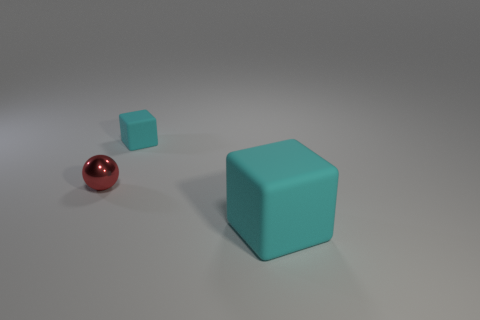What is the shape of the rubber thing that is to the right of the cyan matte object behind the ball?
Your response must be concise. Cube. Do the small cyan object behind the big cyan rubber block and the red object have the same material?
Your answer should be compact. No. How many cyan objects are either rubber things or big cubes?
Your answer should be very brief. 2. Are there any objects that have the same color as the large rubber cube?
Your response must be concise. Yes. Is there a tiny object that has the same material as the large object?
Ensure brevity in your answer.  Yes. What shape is the object that is in front of the small matte object and on the right side of the small red shiny sphere?
Give a very brief answer. Cube. How many large objects are cyan matte objects or red metal things?
Your response must be concise. 1. What material is the large cube?
Your response must be concise. Rubber. How many other objects are the same shape as the tiny red object?
Provide a short and direct response. 0. There is a object that is both right of the red thing and in front of the tiny cyan cube; what size is it?
Your response must be concise. Large. 